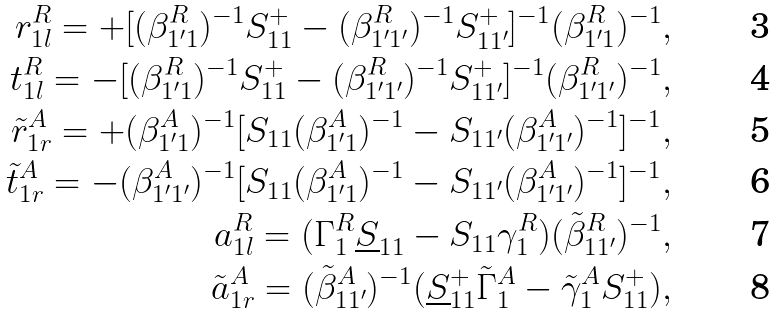<formula> <loc_0><loc_0><loc_500><loc_500>r _ { 1 l } ^ { R } = + [ ( \beta _ { 1 ^ { \prime } 1 } ^ { R } ) ^ { - 1 } S _ { 1 1 } ^ { + } - ( \beta _ { 1 ^ { \prime } 1 ^ { \prime } } ^ { R } ) ^ { - 1 } S _ { 1 1 ^ { \prime } } ^ { + } ] ^ { - 1 } ( \beta _ { 1 ^ { \prime } 1 } ^ { R } ) ^ { - 1 } , \\ t _ { 1 l } ^ { R } = - [ ( \beta _ { 1 ^ { \prime } 1 } ^ { R } ) ^ { - 1 } S _ { 1 1 } ^ { + } - ( \beta _ { 1 ^ { \prime } 1 ^ { \prime } } ^ { R } ) ^ { - 1 } S _ { 1 1 ^ { \prime } } ^ { + } ] ^ { - 1 } ( \beta _ { 1 ^ { \prime } 1 ^ { \prime } } ^ { R } ) ^ { - 1 } , \\ \tilde { r } _ { 1 r } ^ { A } = + ( \beta _ { 1 ^ { \prime } 1 } ^ { A } ) ^ { - 1 } [ S _ { 1 1 } ( \beta _ { 1 ^ { \prime } 1 } ^ { A } ) ^ { - 1 } - S _ { 1 1 ^ { \prime } } ( \beta _ { 1 ^ { \prime } 1 ^ { \prime } } ^ { A } ) ^ { - 1 } ] ^ { - 1 } , \\ \tilde { t } _ { 1 r } ^ { A } = - ( \beta _ { 1 ^ { \prime } 1 ^ { \prime } } ^ { A } ) ^ { - 1 } [ S _ { 1 1 } ( \beta _ { 1 ^ { \prime } 1 } ^ { A } ) ^ { - 1 } - S _ { 1 1 ^ { \prime } } ( \beta _ { 1 ^ { \prime } 1 ^ { \prime } } ^ { A } ) ^ { - 1 } ] ^ { - 1 } , \\ a _ { 1 l } ^ { R } = ( \Gamma _ { 1 } ^ { R } \underline { S } _ { 1 1 } - S _ { 1 1 } \gamma _ { 1 } ^ { R } ) ( \tilde { \beta } _ { 1 1 ^ { \prime } } ^ { R } ) ^ { - 1 } , \\ \tilde { a } _ { 1 r } ^ { A } = ( \tilde { \beta } _ { 1 1 ^ { \prime } } ^ { A } ) ^ { - 1 } ( \underline { S } _ { 1 1 } ^ { + } \tilde { \Gamma } _ { 1 } ^ { A } - \tilde { \gamma } _ { 1 } ^ { A } S _ { 1 1 } ^ { + } ) ,</formula> 